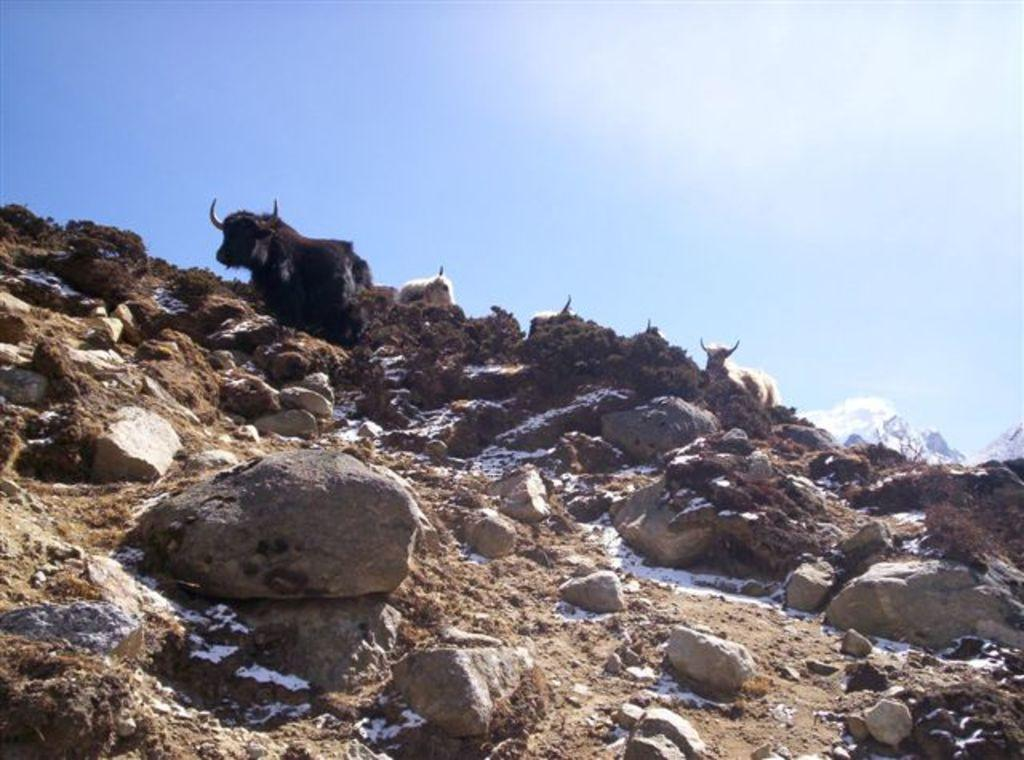What is at the bottom of the image? There is sand and rocks at the bottom of the image. What type of animals can be seen in the image? There are animals in the image. What is visible at the top of the image? The sky is visible at the top of the image. What type of instrument is being played by the animals in the image? There are no instruments present in the image, and the animals are not playing any instruments. Can you describe the wall in the image? There is no wall present in the image. 